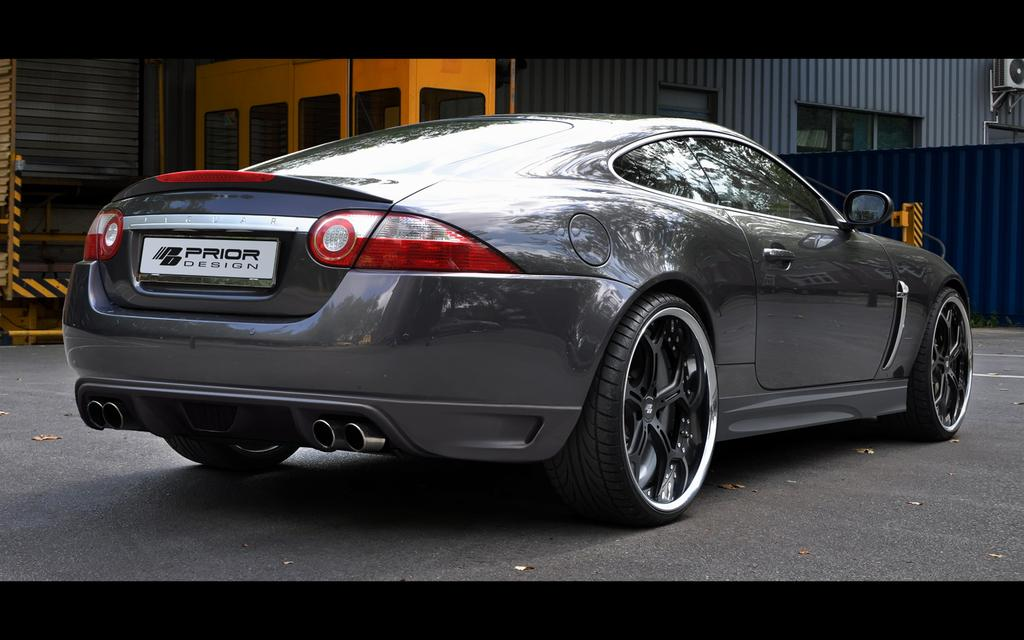What is the main subject of the image? The main subject of the image is a car. Where is the car located in the image? The car is on the road in the image. What can be seen in the background of the image? There are buildings and a wall in the background of the image. What arithmetic problem is being solved on the car's windshield in the image? There is no arithmetic problem visible on the car's windshield in the image. What type of harmony is being played by the buildings in the background? The buildings in the background are not playing any type of harmony; they are stationary structures. 